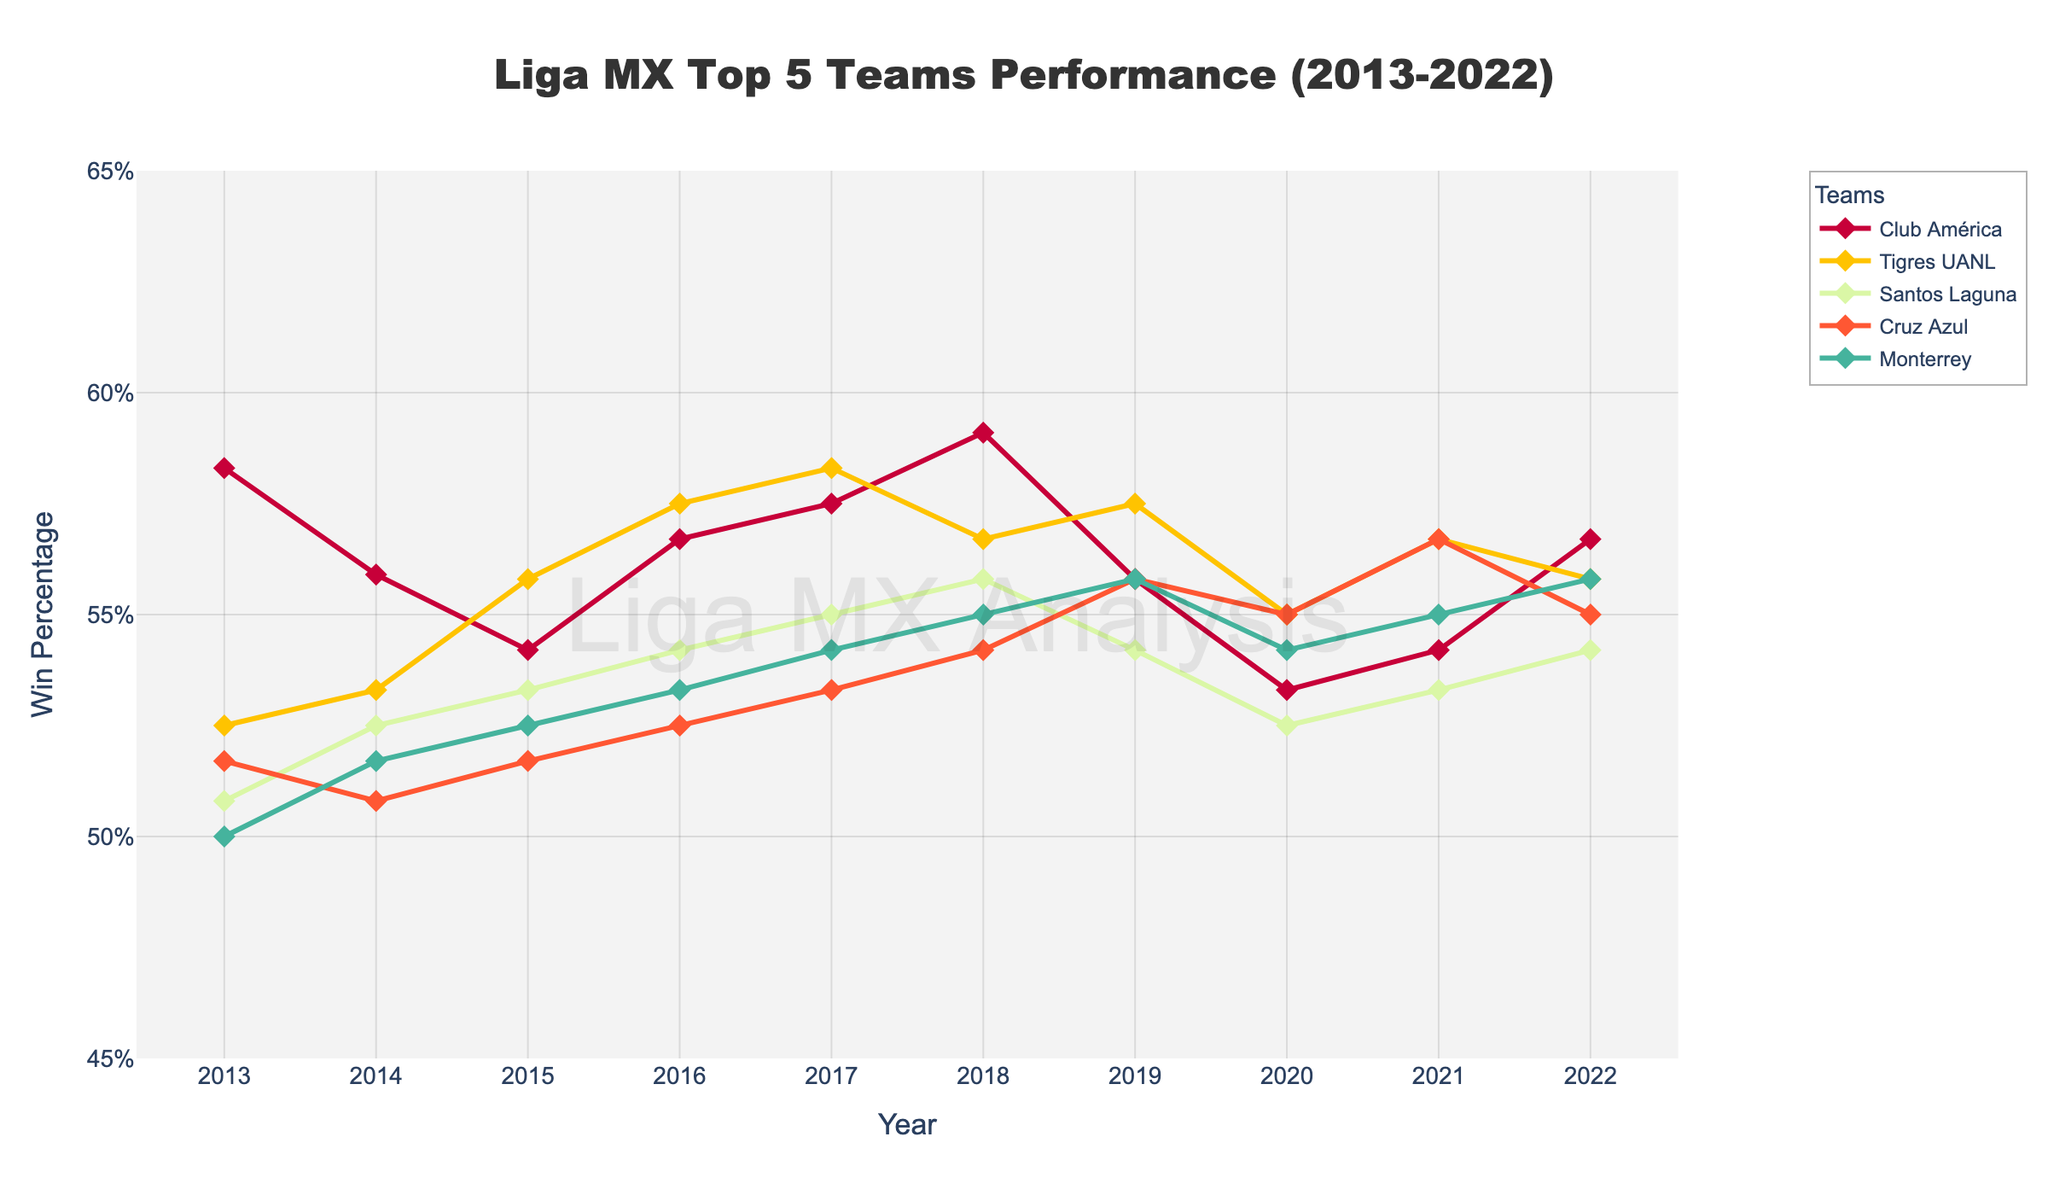What is the overall trend in win percentage for Club América from 2013 to 2022? To find the trend, observe the year-wise data points for Club América: 58.3, 55.9, 54.2, 56.7, 57.5, 59.1, 55.8, 53.3, 54.2, and 56.7. Overall, there is a subtle increase-decrease pattern with fluctuations, but the win percentage remains relatively stable around mid-50s.
Answer: Stable with fluctuations Which team had the highest win percentage in 2018? Look at the data points for 2018 across all teams: Club América (59.1), Tigres UANL (56.7), Santos Laguna (55.8), Cruz Azul (54.2), Monterrey (55.0). Club América had the highest win percentage in 2018.
Answer: Club América In which year did Monterrey experience the largest increase in win percentage compared to the previous year? Compare year-on-year win percentages for Monterrey: 50.0 (2013), 51.7 (2014), 52.5 (2015), 53.3 (2016), 54.2 (2017), 55.0 (2018), 55.8 (2019), 54.2 (2020), 55.0 (2021), and 55.8 (2022). The largest increase is from 2017 to 2018 (54.2 to 55.0, a 0.8% increase).
Answer: 2017 to 2018 How many teams had an increasing win percentage trend from 2020 to 2021? For each team, check if the win percentage in 2021 is higher than in 2020: Club América (53.3 to 54.2), Tigres UANL (55.0 to 56.7), Santos Laguna (52.5 to 53.3), Cruz Azul (55.0 to 56.7), Monterrey (54.2 to 55.0). All five teams show an increase.
Answer: 5 teams Compare the win percentage of Cruz Azul and Santos Laguna in 2019. Which team performed better? For 2019, Cruz Azul's win percentage is 55.8, while Santos Laguna's is 54.2. Thus, Cruz Azul performed better.
Answer: Cruz Azul Did Tigres UANL ever have a higher win percentage than Club América? If so, in which year(s)? Compare the win percentages of Tigres UANL and Club América for each year. Tigres UANL had higher win percentages in 2015 (55.8 vs. 54.2) and 2017 (58.3 vs. 57.5).
Answer: 2015 and 2017 Which team's win percentage was the lowest in 2013? Look at the win percentages for 2013: Club América (58.3), Tigres UANL (52.5), Santos Laguna (50.8), Cruz Azul (51.7), Monterrey (50.0). Monterrey had the lowest win percentage in 2013.
Answer: Monterrey What was the average win percentage of Cruz Azul for the given period from 2013 to 2022? Sum Cruz Azul's win percentages for each year: 51.7, 50.8, 51.7, 52.5, 53.3, 54.2, 55.8, 55.0, 56.7, and 55.0. Total is 536.7. Divide by the number of years (10): 536.7 / 10 = 53.67%.
Answer: 53.67% Which team showed the most consistent win percentage, and what pattern supports this conclusion? Assess win percentage fluctuations for all teams. Club América's win percentages range from 53.3 to 59.1 with moderate fluctuations but generally hover around mid-50s, indicating relative consistency.
Answer: Club América 